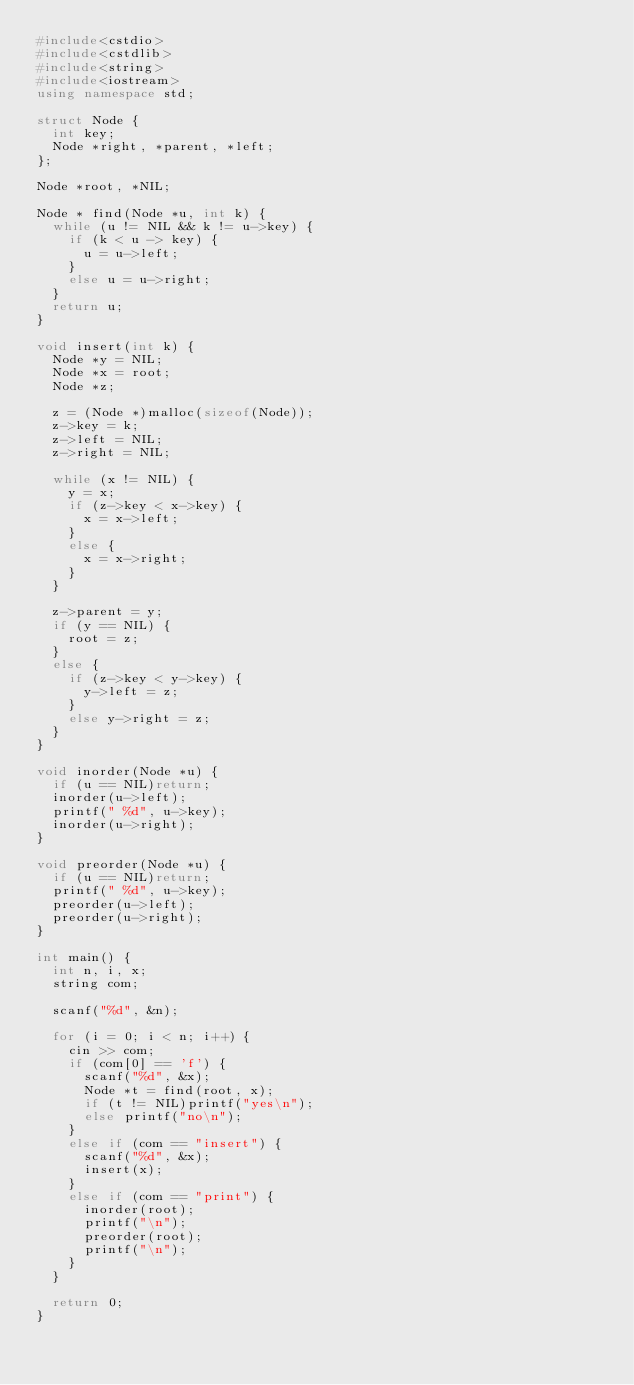Convert code to text. <code><loc_0><loc_0><loc_500><loc_500><_C++_>#include<cstdio>
#include<cstdlib>
#include<string>
#include<iostream>
using namespace std;

struct Node {
	int key;
	Node *right, *parent, *left;
};

Node *root, *NIL;

Node * find(Node *u, int k) {
	while (u != NIL && k != u->key) {
		if (k < u -> key) {
			u = u->left;
		}
		else u = u->right;
	}
	return u;
}

void insert(int k) {
	Node *y = NIL;
	Node *x = root;
	Node *z;

	z = (Node *)malloc(sizeof(Node));
	z->key = k;
	z->left = NIL;
	z->right = NIL;

	while (x != NIL) {
		y = x;
		if (z->key < x->key) {
			x = x->left;
		}
		else {
			x = x->right;
		}
	}

	z->parent = y;
	if (y == NIL) {
		root = z;
	}
	else {
		if (z->key < y->key) {
			y->left = z;
		}
		else y->right = z;
	}
}

void inorder(Node *u) {
	if (u == NIL)return;
	inorder(u->left);
	printf(" %d", u->key);
	inorder(u->right);
}

void preorder(Node *u) {
	if (u == NIL)return;
	printf(" %d", u->key);
	preorder(u->left);
	preorder(u->right);
}

int main() {
	int n, i, x;
	string com;

	scanf("%d", &n);

	for (i = 0; i < n; i++) {
		cin >> com;
		if (com[0] == 'f') {
			scanf("%d", &x);
			Node *t = find(root, x);
			if (t != NIL)printf("yes\n");
			else printf("no\n");
		}
		else if (com == "insert") {
			scanf("%d", &x);
			insert(x);
		}
		else if (com == "print") {
			inorder(root);
			printf("\n");
			preorder(root);
			printf("\n");
		}
	}

	return 0;
}
</code> 